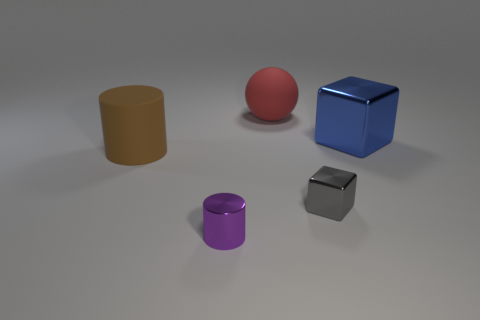How would these objects look in a real-world setting, and what materials might they be made from? In a real-world setting, these objects might resemble toys or decorative items. Their smooth surfaces and distinct colors suggest they could be made of plastic or possibly painted wood. 